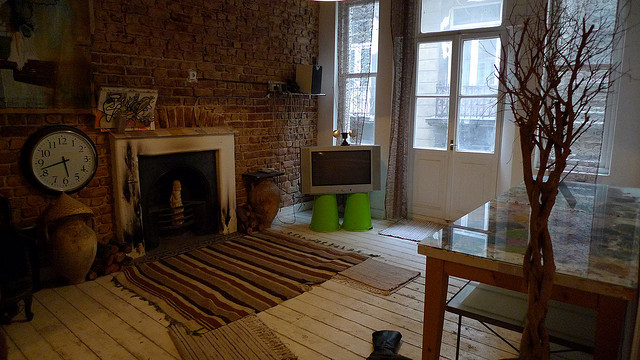How many clocks do you see? There is one clock visible in the image. It's positioned on the wall to the left of the fireplace. 